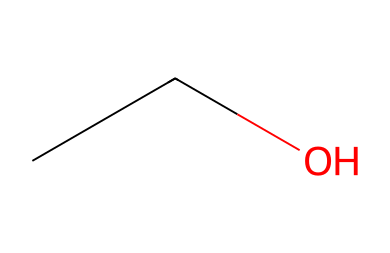What is the molecular formula of this compound? The SMILES representation "CCO" indicates there are two carbon atoms (C2) and six hydrogen atoms (H6) and one oxygen atom (O). Combining these gives the molecular formula C2H6O.
Answer: C2H6O How many oxygen atoms are present in this chemical? In the SMILES code "CCO", there is a single "O" which represents one oxygen atom.
Answer: one What type of chemical structure does this represent? The presence of an ether functional group can be inferred from the SMILES "CCO", meaning it is classified as an alcohol rather than a standard ether.
Answer: alcohol What is the total number of atoms in this compound? The SMILES "CCO" shows the compound consists of two carbons, six hydrogens, and one oxygen, totaling nine atoms.
Answer: nine Why is this compound soluble in water? The presence of the hydroxyl (-OH) group in the alcohol structure enhances its ability to form hydrogen bonds with water molecules, leading to its solubility.
Answer: hydrogen bonds Does this compound have a sweet or bitter taste? Ethanol, represented by "CCO," is generally perceived to have a mild sweetness rather than a bitterness, correlating with its common usage in beverages.
Answer: sweet 